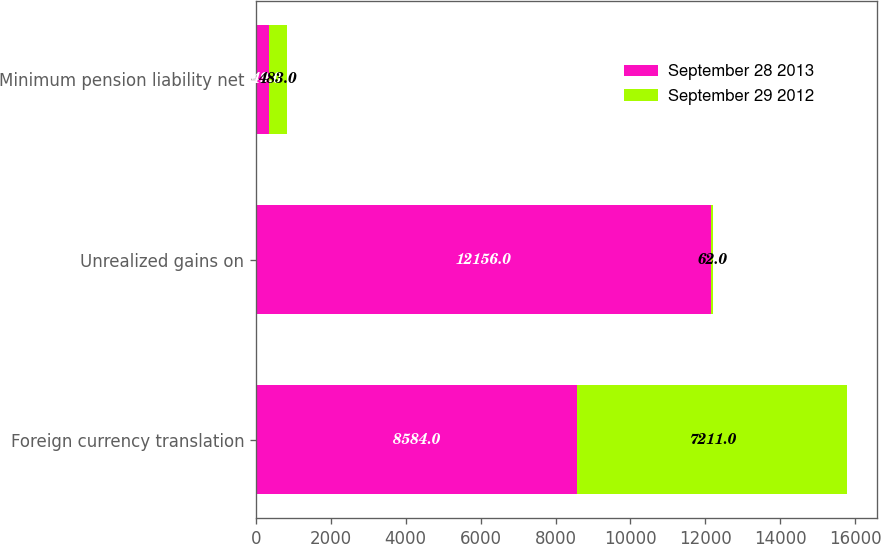Convert chart. <chart><loc_0><loc_0><loc_500><loc_500><stacked_bar_chart><ecel><fcel>Foreign currency translation<fcel>Unrealized gains on<fcel>Minimum pension liability net<nl><fcel>September 28 2013<fcel>8584<fcel>12156<fcel>349<nl><fcel>September 29 2012<fcel>7211<fcel>62<fcel>483<nl></chart> 